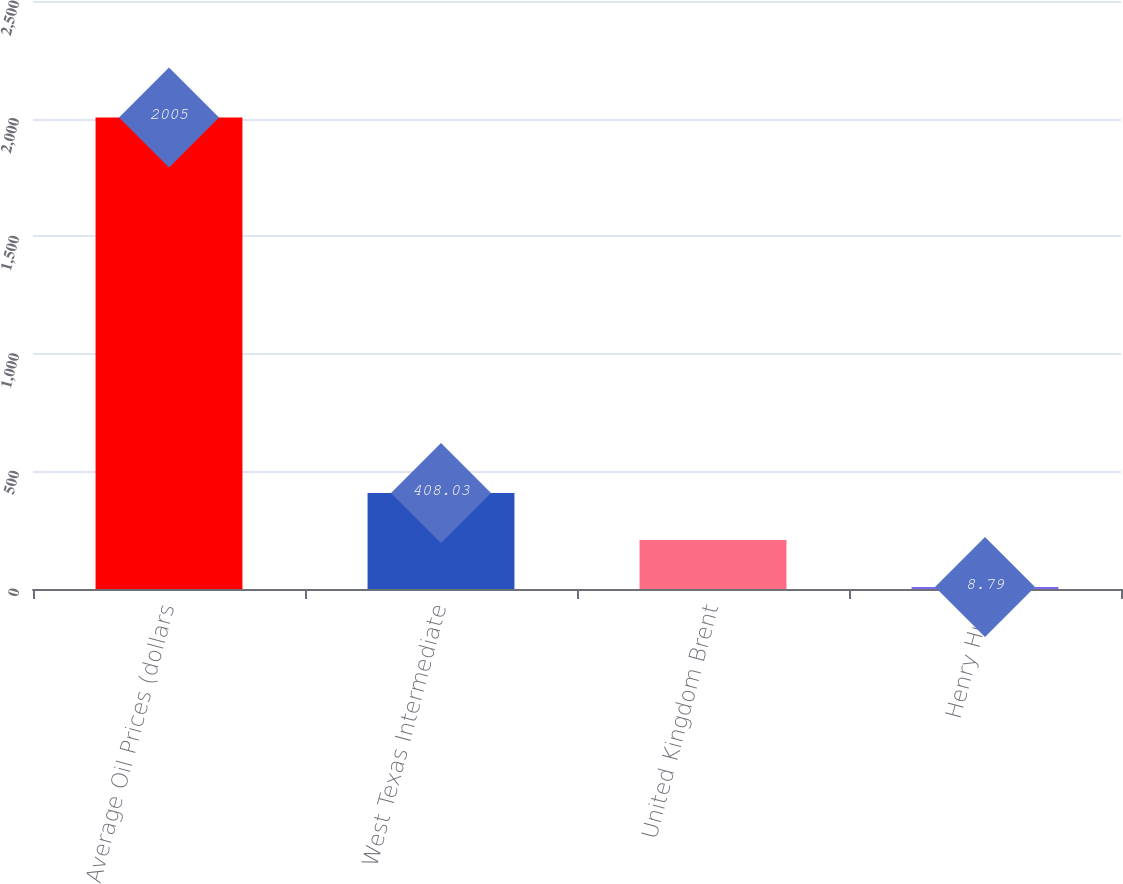Convert chart. <chart><loc_0><loc_0><loc_500><loc_500><bar_chart><fcel>Average Oil Prices (dollars<fcel>West Texas Intermediate<fcel>United Kingdom Brent<fcel>Henry Hub<nl><fcel>2005<fcel>408.03<fcel>208.41<fcel>8.79<nl></chart> 